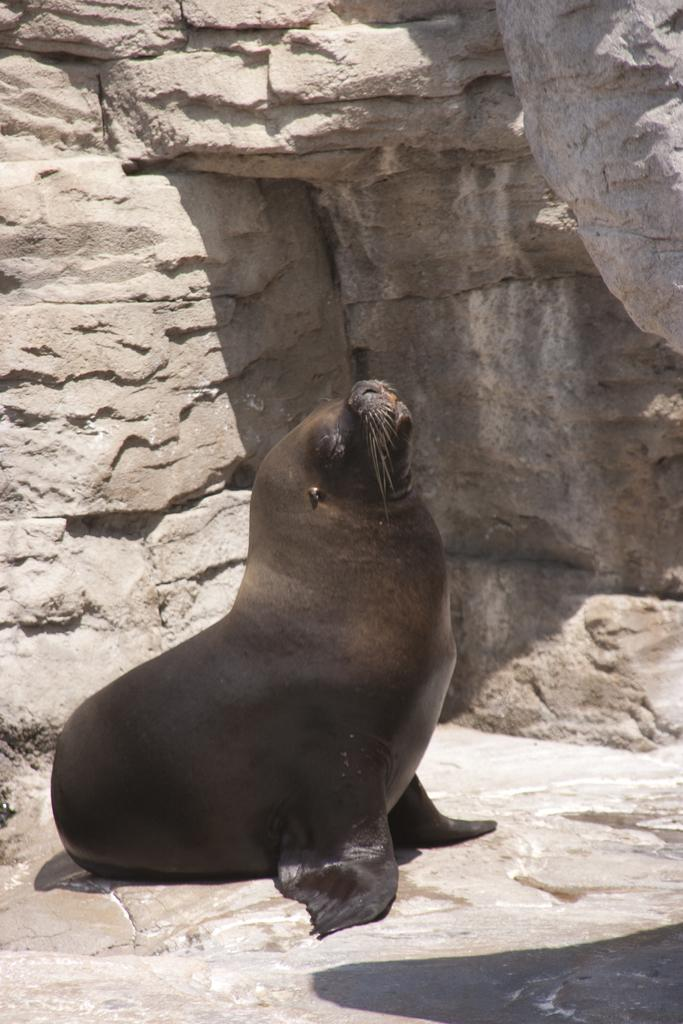What type of animal is in the image? There is a California sea lion in the image. What is the background of the image? There is a rock hill in the image. How many points are on the list of knots in the image? There is no list or knots present in the image; it features a California sea lion and a rock hill. 